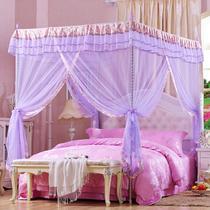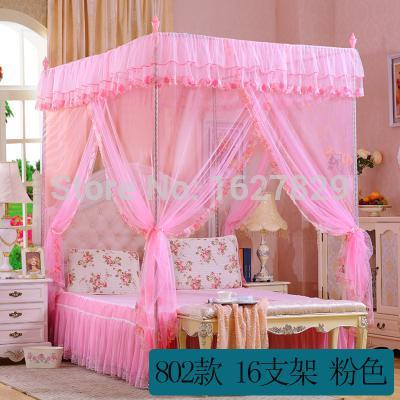The first image is the image on the left, the second image is the image on the right. Analyze the images presented: Is the assertion "The canopy on the right is a purple or lavender shade, while the canopy on the left is clearly pink." valid? Answer yes or no. No. The first image is the image on the left, the second image is the image on the right. Assess this claim about the two images: "The image on the right contains a bed set with a purple net canopy.". Correct or not? Answer yes or no. No. 